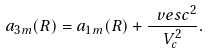<formula> <loc_0><loc_0><loc_500><loc_500>a _ { 3 m } ( R ) = a _ { 1 m } ( R ) + \frac { \ v e s c ^ { 2 } } { V _ { c } ^ { 2 } } .</formula> 